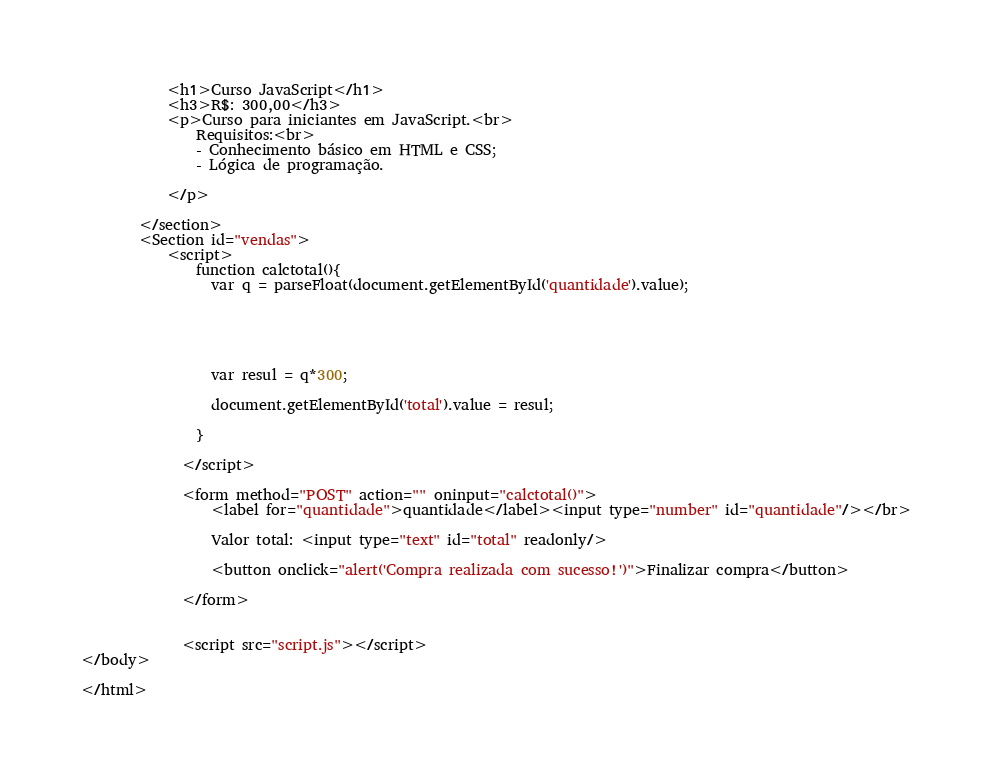<code> <loc_0><loc_0><loc_500><loc_500><_HTML_>            <h1>Curso JavaScript</h1>
            <h3>R$: 300,00</h3>
            <p>Curso para iniciantes em JavaScript.<br>
                Requisitos:<br>
                - Conhecimento básico em HTML e CSS;
                - Lógica de programação.

            </p>

        </section>
        <Section id="vendas">
            <script>
                function calctotal(){
                  var q = parseFloat(document.getElementById('quantidade').value);
          
                  
                 
                  
          
                  var resul = q*300;
          
                  document.getElementById('total').value = resul;
          
                }
          
              </script>
          
              <form method="POST" action="" oninput="calctotal()">
                  <label for="quantidade">quantidade</label><input type="number" id="quantidade"/></br>
                  
                  Valor total: <input type="text" id="total" readonly/> 
          
                  <button onclick="alert('Compra realizada com sucesso!')">Finalizar compra</button>
          
              </form>
          
          
              <script src="script.js"></script>
</body>

</html></code> 